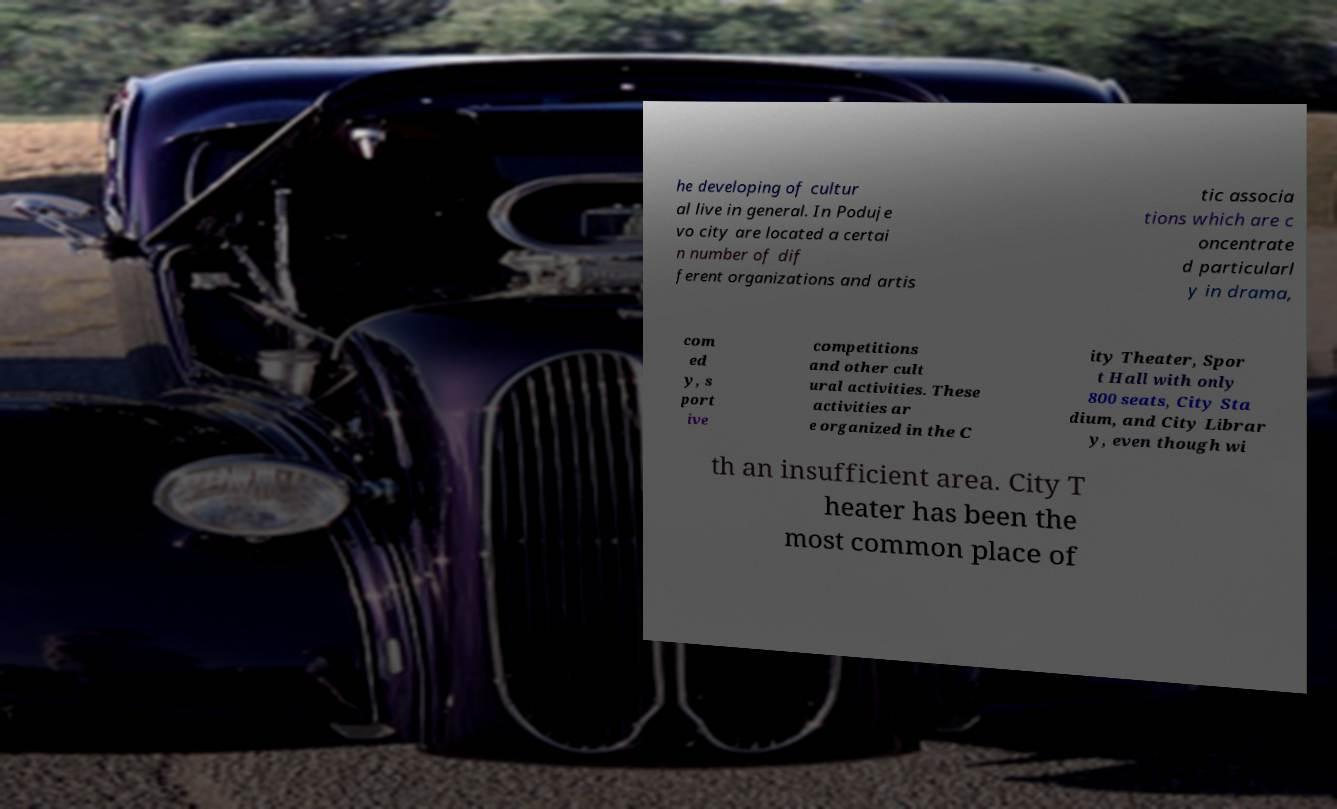Could you assist in decoding the text presented in this image and type it out clearly? he developing of cultur al live in general. In Poduje vo city are located a certai n number of dif ferent organizations and artis tic associa tions which are c oncentrate d particularl y in drama, com ed y, s port ive competitions and other cult ural activities. These activities ar e organized in the C ity Theater, Spor t Hall with only 800 seats, City Sta dium, and City Librar y, even though wi th an insufficient area. City T heater has been the most common place of 